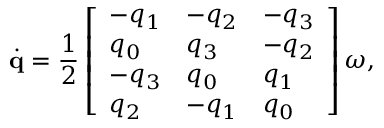<formula> <loc_0><loc_0><loc_500><loc_500>\dot { q } = \frac { 1 } { 2 } \left [ \begin{array} { l l l } { - q _ { 1 } } & { - q _ { 2 } } & { - q _ { 3 } } \\ { q _ { 0 } } & { q _ { 3 } } & { - q _ { 2 } } \\ { - q _ { 3 } } & { q _ { 0 } } & { q _ { 1 } } \\ { q _ { 2 } } & { - q _ { 1 } } & { q _ { 0 } } \end{array} \right ] \boldsymbol \omega ,</formula> 